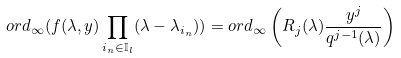Convert formula to latex. <formula><loc_0><loc_0><loc_500><loc_500>o r d _ { \infty } ( f ( \lambda , y ) \prod _ { i _ { n } \in \mathbb { I } _ { l } } ( \lambda - \lambda _ { i _ { n } } ) ) = o r d _ { \infty } \left ( R _ { j } ( \lambda ) \frac { y ^ { j } } { q ^ { j - 1 } ( \lambda ) } \right )</formula> 